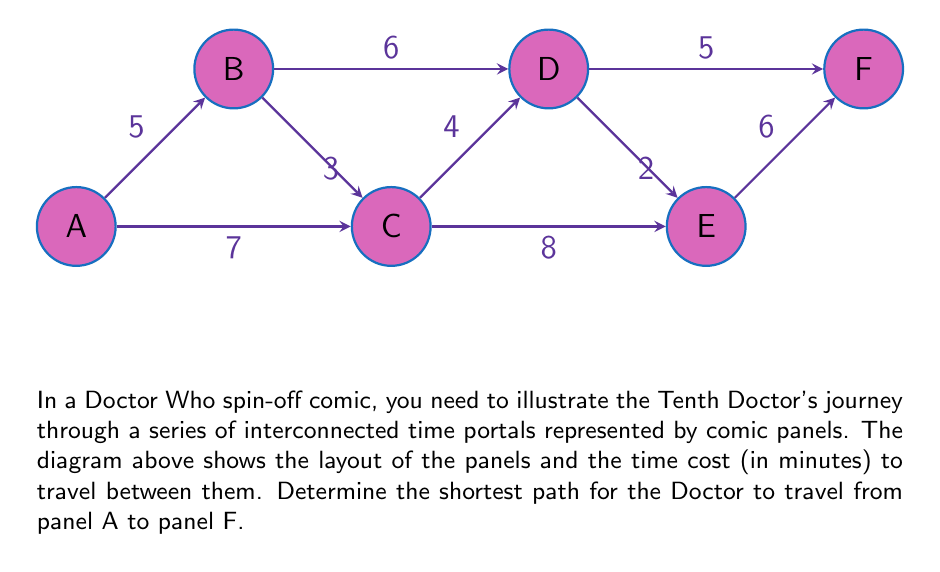Show me your answer to this math problem. To solve this problem, we can use Dijkstra's algorithm to find the shortest path from A to F. Let's go through the steps:

1) Initialize distances:
   $d(A) = 0$, $d(B) = \infty$, $d(C) = \infty$, $d(D) = \infty$, $d(E) = \infty$, $d(F) = \infty$

2) Start from A:
   Update neighbors of A:
   $d(B) = \min(d(B), d(A) + 5) = 5$
   $d(C) = \min(d(C), d(A) + 7) = 7$

3) Choose the vertex with the smallest distance (B):
   Update neighbors of B:
   $d(C) = \min(d(C), d(B) + 3) = \min(7, 8) = 7$
   $d(D) = \min(d(D), d(B) + 6) = 11$

4) Choose the next smallest (C):
   Update neighbors of C:
   $d(D) = \min(d(D), d(C) + 4) = \min(11, 11) = 11$
   $d(E) = \min(d(E), d(C) + 8) = 15$

5) Choose D:
   Update neighbors of D:
   $d(E) = \min(d(E), d(D) + 2) = \min(15, 13) = 13$
   $d(F) = \min(d(F), d(D) + 5) = 16$

6) Choose E:
   Update neighbors of E:
   $d(F) = \min(d(F), d(E) + 6) = \min(16, 19) = 16$

7) Finally, reach F with a total distance of 16.

The shortest path is A -> B -> C -> D -> F, with a total time of 16 minutes.
Answer: A -> B -> C -> D -> F, 16 minutes 